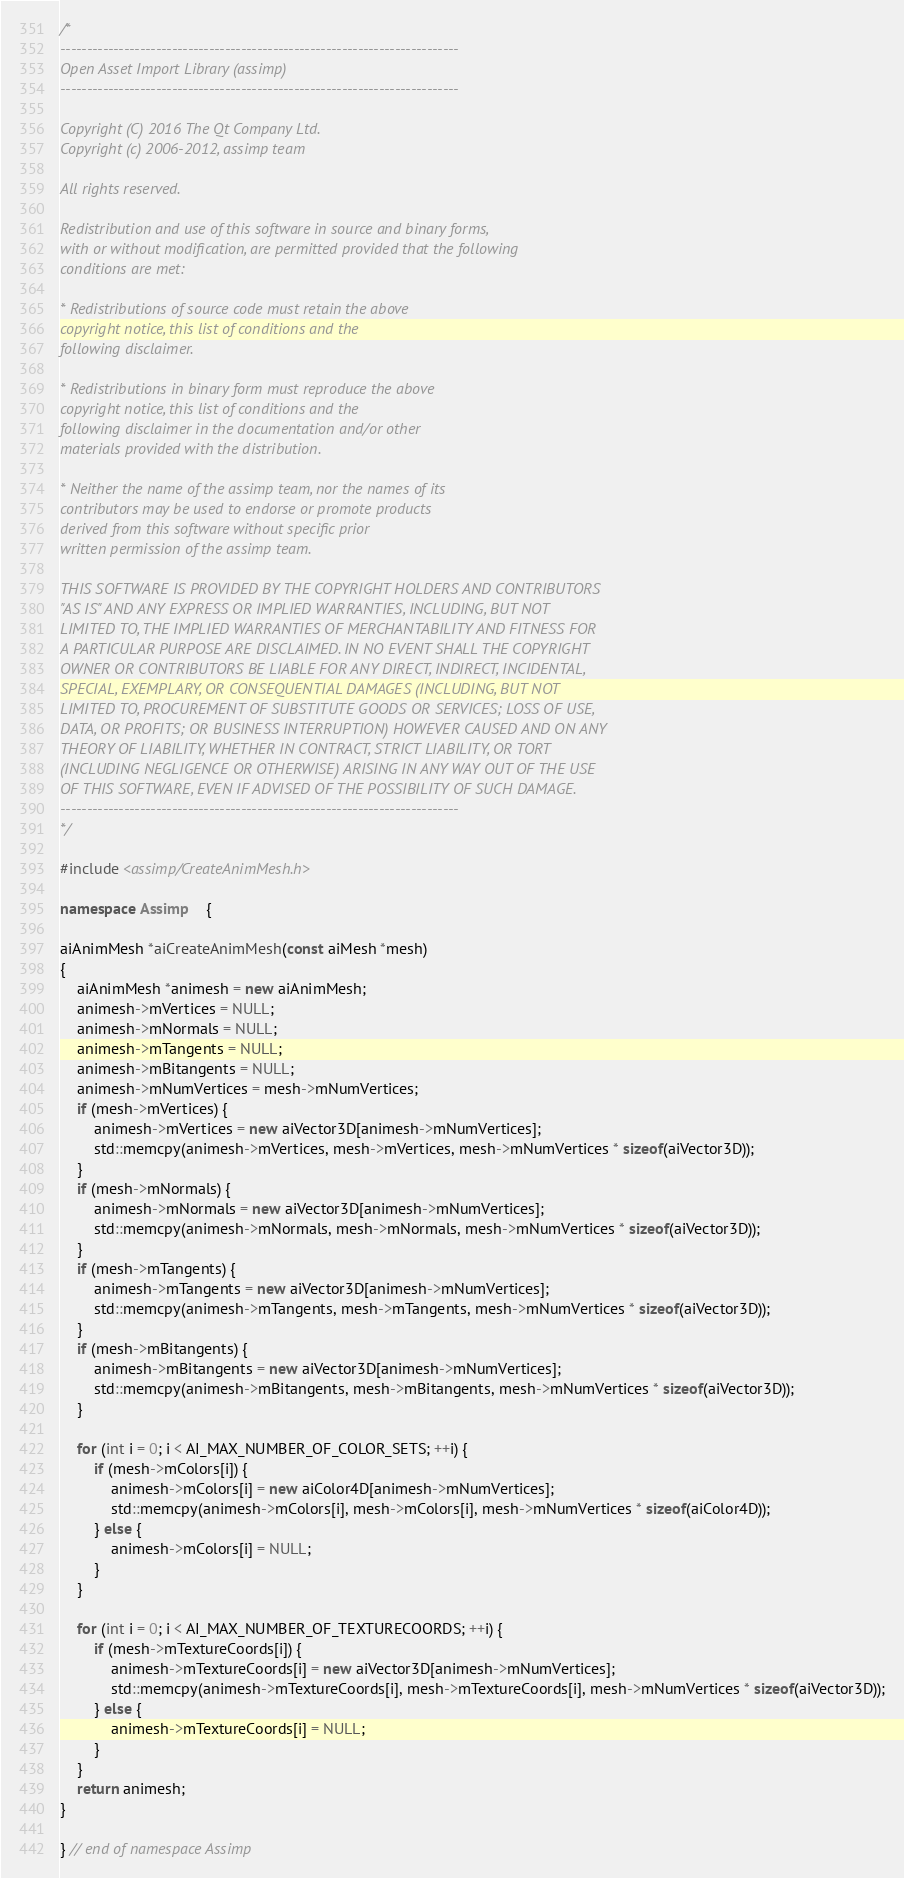Convert code to text. <code><loc_0><loc_0><loc_500><loc_500><_C++_>/*
---------------------------------------------------------------------------
Open Asset Import Library (assimp)
---------------------------------------------------------------------------

Copyright (C) 2016 The Qt Company Ltd.
Copyright (c) 2006-2012, assimp team

All rights reserved.

Redistribution and use of this software in source and binary forms,
with or without modification, are permitted provided that the following
conditions are met:

* Redistributions of source code must retain the above
copyright notice, this list of conditions and the
following disclaimer.

* Redistributions in binary form must reproduce the above
copyright notice, this list of conditions and the
following disclaimer in the documentation and/or other
materials provided with the distribution.

* Neither the name of the assimp team, nor the names of its
contributors may be used to endorse or promote products
derived from this software without specific prior
written permission of the assimp team.

THIS SOFTWARE IS PROVIDED BY THE COPYRIGHT HOLDERS AND CONTRIBUTORS
"AS IS" AND ANY EXPRESS OR IMPLIED WARRANTIES, INCLUDING, BUT NOT
LIMITED TO, THE IMPLIED WARRANTIES OF MERCHANTABILITY AND FITNESS FOR
A PARTICULAR PURPOSE ARE DISCLAIMED. IN NO EVENT SHALL THE COPYRIGHT
OWNER OR CONTRIBUTORS BE LIABLE FOR ANY DIRECT, INDIRECT, INCIDENTAL,
SPECIAL, EXEMPLARY, OR CONSEQUENTIAL DAMAGES (INCLUDING, BUT NOT
LIMITED TO, PROCUREMENT OF SUBSTITUTE GOODS OR SERVICES; LOSS OF USE,
DATA, OR PROFITS; OR BUSINESS INTERRUPTION) HOWEVER CAUSED AND ON ANY
THEORY OF LIABILITY, WHETHER IN CONTRACT, STRICT LIABILITY, OR TORT
(INCLUDING NEGLIGENCE OR OTHERWISE) ARISING IN ANY WAY OUT OF THE USE
OF THIS SOFTWARE, EVEN IF ADVISED OF THE POSSIBILITY OF SUCH DAMAGE.
---------------------------------------------------------------------------
*/

#include <assimp/CreateAnimMesh.h>

namespace Assimp    {

aiAnimMesh *aiCreateAnimMesh(const aiMesh *mesh)
{
    aiAnimMesh *animesh = new aiAnimMesh;
    animesh->mVertices = NULL;
    animesh->mNormals = NULL;
    animesh->mTangents = NULL;
    animesh->mBitangents = NULL;
    animesh->mNumVertices = mesh->mNumVertices;
    if (mesh->mVertices) {
        animesh->mVertices = new aiVector3D[animesh->mNumVertices];
        std::memcpy(animesh->mVertices, mesh->mVertices, mesh->mNumVertices * sizeof(aiVector3D));
    }
    if (mesh->mNormals) {
        animesh->mNormals = new aiVector3D[animesh->mNumVertices];
        std::memcpy(animesh->mNormals, mesh->mNormals, mesh->mNumVertices * sizeof(aiVector3D));
    }
    if (mesh->mTangents) {
        animesh->mTangents = new aiVector3D[animesh->mNumVertices];
        std::memcpy(animesh->mTangents, mesh->mTangents, mesh->mNumVertices * sizeof(aiVector3D));
    }
    if (mesh->mBitangents) {
        animesh->mBitangents = new aiVector3D[animesh->mNumVertices];
        std::memcpy(animesh->mBitangents, mesh->mBitangents, mesh->mNumVertices * sizeof(aiVector3D));
    }

    for (int i = 0; i < AI_MAX_NUMBER_OF_COLOR_SETS; ++i) {
        if (mesh->mColors[i]) {
            animesh->mColors[i] = new aiColor4D[animesh->mNumVertices];
            std::memcpy(animesh->mColors[i], mesh->mColors[i], mesh->mNumVertices * sizeof(aiColor4D));
        } else {
            animesh->mColors[i] = NULL;
        }
    }

    for (int i = 0; i < AI_MAX_NUMBER_OF_TEXTURECOORDS; ++i) {
        if (mesh->mTextureCoords[i]) {
            animesh->mTextureCoords[i] = new aiVector3D[animesh->mNumVertices];
            std::memcpy(animesh->mTextureCoords[i], mesh->mTextureCoords[i], mesh->mNumVertices * sizeof(aiVector3D));
        } else {
            animesh->mTextureCoords[i] = NULL;
        }
    }
    return animesh;
}

} // end of namespace Assimp
</code> 